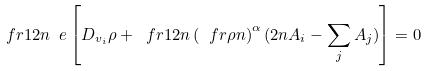<formula> <loc_0><loc_0><loc_500><loc_500>\ f r { 1 } { 2 n \ e } \left [ D _ { v _ { i } } \rho + \ f r { 1 } { 2 n } \left ( \ f r { \rho } { n } \right ) ^ { \alpha } ( 2 n A _ { i } - \sum _ { j } A _ { j } ) \right ] = 0</formula> 